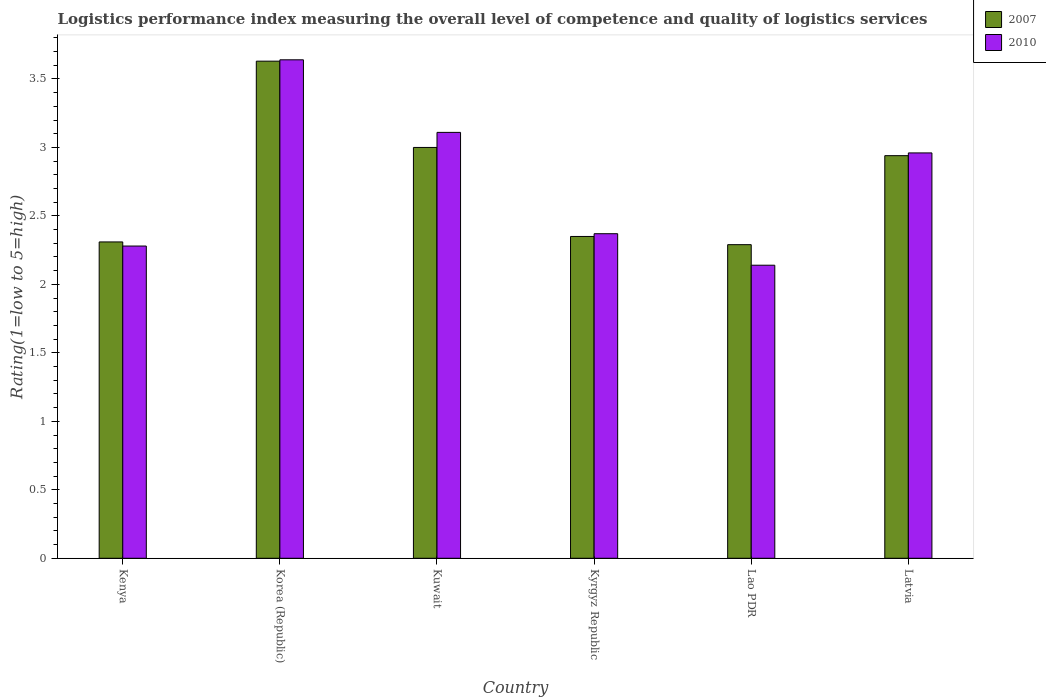Are the number of bars per tick equal to the number of legend labels?
Provide a succinct answer. Yes. Are the number of bars on each tick of the X-axis equal?
Your answer should be very brief. Yes. How many bars are there on the 4th tick from the right?
Give a very brief answer. 2. What is the label of the 1st group of bars from the left?
Your response must be concise. Kenya. In how many cases, is the number of bars for a given country not equal to the number of legend labels?
Provide a short and direct response. 0. What is the Logistic performance index in 2007 in Korea (Republic)?
Keep it short and to the point. 3.63. Across all countries, what is the maximum Logistic performance index in 2010?
Keep it short and to the point. 3.64. Across all countries, what is the minimum Logistic performance index in 2010?
Your answer should be compact. 2.14. In which country was the Logistic performance index in 2010 minimum?
Make the answer very short. Lao PDR. What is the total Logistic performance index in 2007 in the graph?
Provide a succinct answer. 16.52. What is the difference between the Logistic performance index in 2007 in Kenya and that in Kyrgyz Republic?
Your answer should be very brief. -0.04. What is the difference between the Logistic performance index in 2007 in Kuwait and the Logistic performance index in 2010 in Latvia?
Ensure brevity in your answer.  0.04. What is the average Logistic performance index in 2007 per country?
Make the answer very short. 2.75. What is the difference between the Logistic performance index of/in 2010 and Logistic performance index of/in 2007 in Kuwait?
Keep it short and to the point. 0.11. What is the ratio of the Logistic performance index in 2010 in Kuwait to that in Kyrgyz Republic?
Provide a succinct answer. 1.31. What is the difference between the highest and the second highest Logistic performance index in 2007?
Offer a terse response. 0.06. What is the difference between the highest and the lowest Logistic performance index in 2010?
Your answer should be very brief. 1.5. Is the sum of the Logistic performance index in 2010 in Kenya and Kyrgyz Republic greater than the maximum Logistic performance index in 2007 across all countries?
Offer a very short reply. Yes. What does the 1st bar from the right in Korea (Republic) represents?
Offer a very short reply. 2010. How many bars are there?
Ensure brevity in your answer.  12. How many countries are there in the graph?
Your answer should be compact. 6. What is the difference between two consecutive major ticks on the Y-axis?
Your response must be concise. 0.5. Are the values on the major ticks of Y-axis written in scientific E-notation?
Make the answer very short. No. Does the graph contain grids?
Your answer should be compact. No. Where does the legend appear in the graph?
Provide a short and direct response. Top right. How many legend labels are there?
Make the answer very short. 2. How are the legend labels stacked?
Your response must be concise. Vertical. What is the title of the graph?
Keep it short and to the point. Logistics performance index measuring the overall level of competence and quality of logistics services. What is the label or title of the X-axis?
Your answer should be compact. Country. What is the label or title of the Y-axis?
Make the answer very short. Rating(1=low to 5=high). What is the Rating(1=low to 5=high) of 2007 in Kenya?
Provide a succinct answer. 2.31. What is the Rating(1=low to 5=high) in 2010 in Kenya?
Provide a succinct answer. 2.28. What is the Rating(1=low to 5=high) in 2007 in Korea (Republic)?
Provide a short and direct response. 3.63. What is the Rating(1=low to 5=high) in 2010 in Korea (Republic)?
Provide a short and direct response. 3.64. What is the Rating(1=low to 5=high) of 2007 in Kuwait?
Your answer should be compact. 3. What is the Rating(1=low to 5=high) of 2010 in Kuwait?
Provide a succinct answer. 3.11. What is the Rating(1=low to 5=high) in 2007 in Kyrgyz Republic?
Give a very brief answer. 2.35. What is the Rating(1=low to 5=high) of 2010 in Kyrgyz Republic?
Ensure brevity in your answer.  2.37. What is the Rating(1=low to 5=high) of 2007 in Lao PDR?
Provide a short and direct response. 2.29. What is the Rating(1=low to 5=high) in 2010 in Lao PDR?
Your answer should be very brief. 2.14. What is the Rating(1=low to 5=high) of 2007 in Latvia?
Your response must be concise. 2.94. What is the Rating(1=low to 5=high) in 2010 in Latvia?
Keep it short and to the point. 2.96. Across all countries, what is the maximum Rating(1=low to 5=high) of 2007?
Your answer should be very brief. 3.63. Across all countries, what is the maximum Rating(1=low to 5=high) of 2010?
Your answer should be compact. 3.64. Across all countries, what is the minimum Rating(1=low to 5=high) of 2007?
Your answer should be very brief. 2.29. Across all countries, what is the minimum Rating(1=low to 5=high) in 2010?
Your answer should be very brief. 2.14. What is the total Rating(1=low to 5=high) in 2007 in the graph?
Ensure brevity in your answer.  16.52. What is the total Rating(1=low to 5=high) of 2010 in the graph?
Offer a very short reply. 16.5. What is the difference between the Rating(1=low to 5=high) in 2007 in Kenya and that in Korea (Republic)?
Keep it short and to the point. -1.32. What is the difference between the Rating(1=low to 5=high) of 2010 in Kenya and that in Korea (Republic)?
Offer a very short reply. -1.36. What is the difference between the Rating(1=low to 5=high) of 2007 in Kenya and that in Kuwait?
Keep it short and to the point. -0.69. What is the difference between the Rating(1=low to 5=high) in 2010 in Kenya and that in Kuwait?
Your answer should be very brief. -0.83. What is the difference between the Rating(1=low to 5=high) in 2007 in Kenya and that in Kyrgyz Republic?
Offer a very short reply. -0.04. What is the difference between the Rating(1=low to 5=high) of 2010 in Kenya and that in Kyrgyz Republic?
Your answer should be very brief. -0.09. What is the difference between the Rating(1=low to 5=high) in 2007 in Kenya and that in Lao PDR?
Keep it short and to the point. 0.02. What is the difference between the Rating(1=low to 5=high) in 2010 in Kenya and that in Lao PDR?
Your response must be concise. 0.14. What is the difference between the Rating(1=low to 5=high) in 2007 in Kenya and that in Latvia?
Give a very brief answer. -0.63. What is the difference between the Rating(1=low to 5=high) in 2010 in Kenya and that in Latvia?
Keep it short and to the point. -0.68. What is the difference between the Rating(1=low to 5=high) of 2007 in Korea (Republic) and that in Kuwait?
Your answer should be very brief. 0.63. What is the difference between the Rating(1=low to 5=high) in 2010 in Korea (Republic) and that in Kuwait?
Give a very brief answer. 0.53. What is the difference between the Rating(1=low to 5=high) in 2007 in Korea (Republic) and that in Kyrgyz Republic?
Provide a succinct answer. 1.28. What is the difference between the Rating(1=low to 5=high) of 2010 in Korea (Republic) and that in Kyrgyz Republic?
Provide a short and direct response. 1.27. What is the difference between the Rating(1=low to 5=high) in 2007 in Korea (Republic) and that in Lao PDR?
Offer a very short reply. 1.34. What is the difference between the Rating(1=low to 5=high) of 2007 in Korea (Republic) and that in Latvia?
Your answer should be very brief. 0.69. What is the difference between the Rating(1=low to 5=high) in 2010 in Korea (Republic) and that in Latvia?
Offer a very short reply. 0.68. What is the difference between the Rating(1=low to 5=high) in 2007 in Kuwait and that in Kyrgyz Republic?
Give a very brief answer. 0.65. What is the difference between the Rating(1=low to 5=high) of 2010 in Kuwait and that in Kyrgyz Republic?
Your response must be concise. 0.74. What is the difference between the Rating(1=low to 5=high) of 2007 in Kuwait and that in Lao PDR?
Provide a succinct answer. 0.71. What is the difference between the Rating(1=low to 5=high) of 2010 in Kuwait and that in Lao PDR?
Ensure brevity in your answer.  0.97. What is the difference between the Rating(1=low to 5=high) in 2007 in Kuwait and that in Latvia?
Your answer should be very brief. 0.06. What is the difference between the Rating(1=low to 5=high) of 2007 in Kyrgyz Republic and that in Lao PDR?
Your response must be concise. 0.06. What is the difference between the Rating(1=low to 5=high) in 2010 in Kyrgyz Republic and that in Lao PDR?
Keep it short and to the point. 0.23. What is the difference between the Rating(1=low to 5=high) in 2007 in Kyrgyz Republic and that in Latvia?
Your response must be concise. -0.59. What is the difference between the Rating(1=low to 5=high) in 2010 in Kyrgyz Republic and that in Latvia?
Your answer should be very brief. -0.59. What is the difference between the Rating(1=low to 5=high) in 2007 in Lao PDR and that in Latvia?
Keep it short and to the point. -0.65. What is the difference between the Rating(1=low to 5=high) of 2010 in Lao PDR and that in Latvia?
Provide a succinct answer. -0.82. What is the difference between the Rating(1=low to 5=high) of 2007 in Kenya and the Rating(1=low to 5=high) of 2010 in Korea (Republic)?
Your response must be concise. -1.33. What is the difference between the Rating(1=low to 5=high) in 2007 in Kenya and the Rating(1=low to 5=high) in 2010 in Kyrgyz Republic?
Offer a terse response. -0.06. What is the difference between the Rating(1=low to 5=high) of 2007 in Kenya and the Rating(1=low to 5=high) of 2010 in Lao PDR?
Ensure brevity in your answer.  0.17. What is the difference between the Rating(1=low to 5=high) in 2007 in Kenya and the Rating(1=low to 5=high) in 2010 in Latvia?
Your answer should be compact. -0.65. What is the difference between the Rating(1=low to 5=high) in 2007 in Korea (Republic) and the Rating(1=low to 5=high) in 2010 in Kuwait?
Give a very brief answer. 0.52. What is the difference between the Rating(1=low to 5=high) in 2007 in Korea (Republic) and the Rating(1=low to 5=high) in 2010 in Kyrgyz Republic?
Provide a succinct answer. 1.26. What is the difference between the Rating(1=low to 5=high) in 2007 in Korea (Republic) and the Rating(1=low to 5=high) in 2010 in Lao PDR?
Your answer should be compact. 1.49. What is the difference between the Rating(1=low to 5=high) of 2007 in Korea (Republic) and the Rating(1=low to 5=high) of 2010 in Latvia?
Your response must be concise. 0.67. What is the difference between the Rating(1=low to 5=high) in 2007 in Kuwait and the Rating(1=low to 5=high) in 2010 in Kyrgyz Republic?
Provide a short and direct response. 0.63. What is the difference between the Rating(1=low to 5=high) of 2007 in Kuwait and the Rating(1=low to 5=high) of 2010 in Lao PDR?
Give a very brief answer. 0.86. What is the difference between the Rating(1=low to 5=high) in 2007 in Kyrgyz Republic and the Rating(1=low to 5=high) in 2010 in Lao PDR?
Give a very brief answer. 0.21. What is the difference between the Rating(1=low to 5=high) in 2007 in Kyrgyz Republic and the Rating(1=low to 5=high) in 2010 in Latvia?
Make the answer very short. -0.61. What is the difference between the Rating(1=low to 5=high) in 2007 in Lao PDR and the Rating(1=low to 5=high) in 2010 in Latvia?
Give a very brief answer. -0.67. What is the average Rating(1=low to 5=high) in 2007 per country?
Provide a succinct answer. 2.75. What is the average Rating(1=low to 5=high) of 2010 per country?
Give a very brief answer. 2.75. What is the difference between the Rating(1=low to 5=high) of 2007 and Rating(1=low to 5=high) of 2010 in Kenya?
Provide a short and direct response. 0.03. What is the difference between the Rating(1=low to 5=high) in 2007 and Rating(1=low to 5=high) in 2010 in Korea (Republic)?
Offer a very short reply. -0.01. What is the difference between the Rating(1=low to 5=high) in 2007 and Rating(1=low to 5=high) in 2010 in Kuwait?
Your answer should be compact. -0.11. What is the difference between the Rating(1=low to 5=high) in 2007 and Rating(1=low to 5=high) in 2010 in Kyrgyz Republic?
Your answer should be compact. -0.02. What is the difference between the Rating(1=low to 5=high) of 2007 and Rating(1=low to 5=high) of 2010 in Lao PDR?
Offer a very short reply. 0.15. What is the difference between the Rating(1=low to 5=high) of 2007 and Rating(1=low to 5=high) of 2010 in Latvia?
Ensure brevity in your answer.  -0.02. What is the ratio of the Rating(1=low to 5=high) of 2007 in Kenya to that in Korea (Republic)?
Your response must be concise. 0.64. What is the ratio of the Rating(1=low to 5=high) of 2010 in Kenya to that in Korea (Republic)?
Offer a terse response. 0.63. What is the ratio of the Rating(1=low to 5=high) in 2007 in Kenya to that in Kuwait?
Provide a short and direct response. 0.77. What is the ratio of the Rating(1=low to 5=high) of 2010 in Kenya to that in Kuwait?
Offer a very short reply. 0.73. What is the ratio of the Rating(1=low to 5=high) of 2010 in Kenya to that in Kyrgyz Republic?
Offer a terse response. 0.96. What is the ratio of the Rating(1=low to 5=high) of 2007 in Kenya to that in Lao PDR?
Offer a very short reply. 1.01. What is the ratio of the Rating(1=low to 5=high) in 2010 in Kenya to that in Lao PDR?
Provide a short and direct response. 1.07. What is the ratio of the Rating(1=low to 5=high) in 2007 in Kenya to that in Latvia?
Keep it short and to the point. 0.79. What is the ratio of the Rating(1=low to 5=high) of 2010 in Kenya to that in Latvia?
Your answer should be very brief. 0.77. What is the ratio of the Rating(1=low to 5=high) of 2007 in Korea (Republic) to that in Kuwait?
Your response must be concise. 1.21. What is the ratio of the Rating(1=low to 5=high) of 2010 in Korea (Republic) to that in Kuwait?
Make the answer very short. 1.17. What is the ratio of the Rating(1=low to 5=high) in 2007 in Korea (Republic) to that in Kyrgyz Republic?
Your answer should be compact. 1.54. What is the ratio of the Rating(1=low to 5=high) of 2010 in Korea (Republic) to that in Kyrgyz Republic?
Ensure brevity in your answer.  1.54. What is the ratio of the Rating(1=low to 5=high) in 2007 in Korea (Republic) to that in Lao PDR?
Keep it short and to the point. 1.59. What is the ratio of the Rating(1=low to 5=high) in 2010 in Korea (Republic) to that in Lao PDR?
Provide a short and direct response. 1.7. What is the ratio of the Rating(1=low to 5=high) in 2007 in Korea (Republic) to that in Latvia?
Ensure brevity in your answer.  1.23. What is the ratio of the Rating(1=low to 5=high) of 2010 in Korea (Republic) to that in Latvia?
Your answer should be compact. 1.23. What is the ratio of the Rating(1=low to 5=high) in 2007 in Kuwait to that in Kyrgyz Republic?
Make the answer very short. 1.28. What is the ratio of the Rating(1=low to 5=high) in 2010 in Kuwait to that in Kyrgyz Republic?
Make the answer very short. 1.31. What is the ratio of the Rating(1=low to 5=high) of 2007 in Kuwait to that in Lao PDR?
Offer a terse response. 1.31. What is the ratio of the Rating(1=low to 5=high) of 2010 in Kuwait to that in Lao PDR?
Offer a very short reply. 1.45. What is the ratio of the Rating(1=low to 5=high) of 2007 in Kuwait to that in Latvia?
Your answer should be very brief. 1.02. What is the ratio of the Rating(1=low to 5=high) in 2010 in Kuwait to that in Latvia?
Provide a succinct answer. 1.05. What is the ratio of the Rating(1=low to 5=high) in 2007 in Kyrgyz Republic to that in Lao PDR?
Your answer should be very brief. 1.03. What is the ratio of the Rating(1=low to 5=high) in 2010 in Kyrgyz Republic to that in Lao PDR?
Give a very brief answer. 1.11. What is the ratio of the Rating(1=low to 5=high) of 2007 in Kyrgyz Republic to that in Latvia?
Your response must be concise. 0.8. What is the ratio of the Rating(1=low to 5=high) of 2010 in Kyrgyz Republic to that in Latvia?
Provide a short and direct response. 0.8. What is the ratio of the Rating(1=low to 5=high) in 2007 in Lao PDR to that in Latvia?
Offer a very short reply. 0.78. What is the ratio of the Rating(1=low to 5=high) in 2010 in Lao PDR to that in Latvia?
Your answer should be compact. 0.72. What is the difference between the highest and the second highest Rating(1=low to 5=high) in 2007?
Your response must be concise. 0.63. What is the difference between the highest and the second highest Rating(1=low to 5=high) of 2010?
Offer a terse response. 0.53. What is the difference between the highest and the lowest Rating(1=low to 5=high) in 2007?
Offer a terse response. 1.34. 